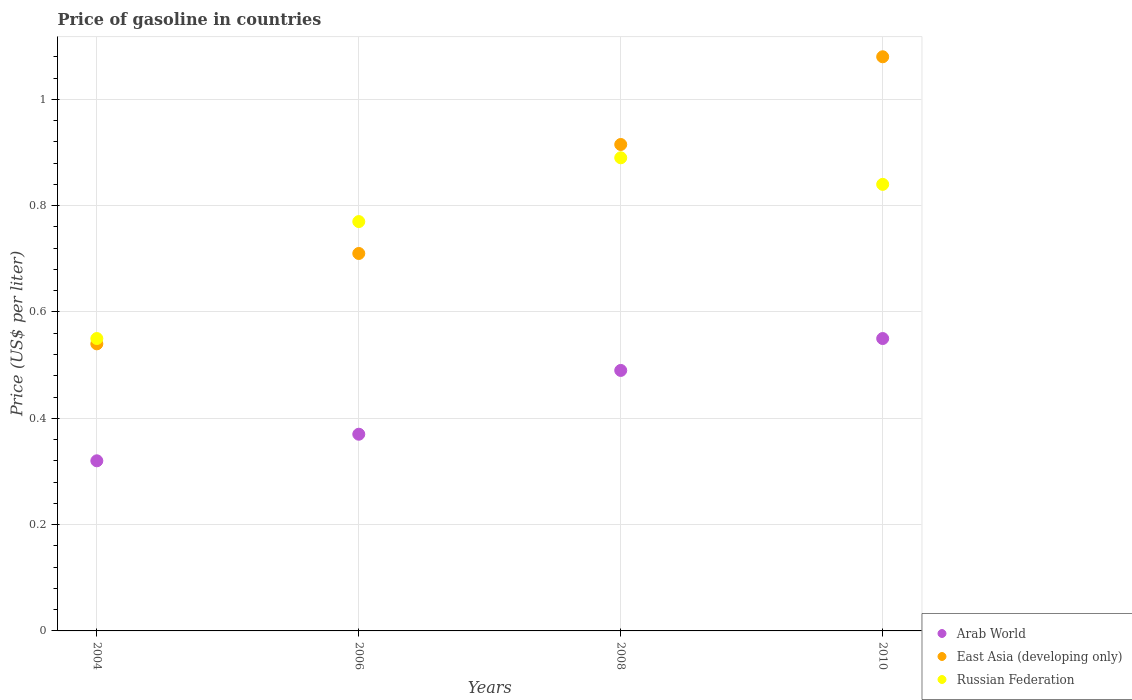Is the number of dotlines equal to the number of legend labels?
Provide a succinct answer. Yes. What is the price of gasoline in East Asia (developing only) in 2008?
Offer a very short reply. 0.92. Across all years, what is the maximum price of gasoline in Arab World?
Your answer should be compact. 0.55. Across all years, what is the minimum price of gasoline in Arab World?
Your response must be concise. 0.32. What is the total price of gasoline in Russian Federation in the graph?
Your answer should be compact. 3.05. What is the difference between the price of gasoline in East Asia (developing only) in 2004 and that in 2006?
Your answer should be compact. -0.17. What is the difference between the price of gasoline in East Asia (developing only) in 2004 and the price of gasoline in Russian Federation in 2008?
Your answer should be very brief. -0.35. What is the average price of gasoline in Arab World per year?
Keep it short and to the point. 0.43. In the year 2008, what is the difference between the price of gasoline in East Asia (developing only) and price of gasoline in Arab World?
Keep it short and to the point. 0.43. In how many years, is the price of gasoline in Arab World greater than 0.52 US$?
Ensure brevity in your answer.  1. What is the ratio of the price of gasoline in Russian Federation in 2006 to that in 2010?
Provide a short and direct response. 0.92. Is the price of gasoline in Arab World in 2008 less than that in 2010?
Your answer should be compact. Yes. What is the difference between the highest and the second highest price of gasoline in Arab World?
Your answer should be compact. 0.06. What is the difference between the highest and the lowest price of gasoline in East Asia (developing only)?
Provide a short and direct response. 0.54. In how many years, is the price of gasoline in East Asia (developing only) greater than the average price of gasoline in East Asia (developing only) taken over all years?
Make the answer very short. 2. Is the sum of the price of gasoline in East Asia (developing only) in 2006 and 2010 greater than the maximum price of gasoline in Russian Federation across all years?
Offer a very short reply. Yes. Is it the case that in every year, the sum of the price of gasoline in East Asia (developing only) and price of gasoline in Russian Federation  is greater than the price of gasoline in Arab World?
Offer a terse response. Yes. Does the price of gasoline in Russian Federation monotonically increase over the years?
Your answer should be compact. No. How many dotlines are there?
Make the answer very short. 3. How many years are there in the graph?
Keep it short and to the point. 4. What is the difference between two consecutive major ticks on the Y-axis?
Provide a succinct answer. 0.2. Does the graph contain grids?
Your answer should be compact. Yes. What is the title of the graph?
Keep it short and to the point. Price of gasoline in countries. Does "Colombia" appear as one of the legend labels in the graph?
Your answer should be very brief. No. What is the label or title of the X-axis?
Provide a succinct answer. Years. What is the label or title of the Y-axis?
Keep it short and to the point. Price (US$ per liter). What is the Price (US$ per liter) of Arab World in 2004?
Provide a succinct answer. 0.32. What is the Price (US$ per liter) of East Asia (developing only) in 2004?
Ensure brevity in your answer.  0.54. What is the Price (US$ per liter) in Russian Federation in 2004?
Offer a very short reply. 0.55. What is the Price (US$ per liter) of Arab World in 2006?
Make the answer very short. 0.37. What is the Price (US$ per liter) of East Asia (developing only) in 2006?
Keep it short and to the point. 0.71. What is the Price (US$ per liter) in Russian Federation in 2006?
Your answer should be very brief. 0.77. What is the Price (US$ per liter) in Arab World in 2008?
Offer a terse response. 0.49. What is the Price (US$ per liter) in East Asia (developing only) in 2008?
Offer a very short reply. 0.92. What is the Price (US$ per liter) of Russian Federation in 2008?
Provide a succinct answer. 0.89. What is the Price (US$ per liter) in Arab World in 2010?
Your answer should be compact. 0.55. What is the Price (US$ per liter) in East Asia (developing only) in 2010?
Make the answer very short. 1.08. What is the Price (US$ per liter) in Russian Federation in 2010?
Your answer should be compact. 0.84. Across all years, what is the maximum Price (US$ per liter) of Arab World?
Your answer should be compact. 0.55. Across all years, what is the maximum Price (US$ per liter) of Russian Federation?
Keep it short and to the point. 0.89. Across all years, what is the minimum Price (US$ per liter) in Arab World?
Give a very brief answer. 0.32. Across all years, what is the minimum Price (US$ per liter) in East Asia (developing only)?
Your answer should be compact. 0.54. Across all years, what is the minimum Price (US$ per liter) in Russian Federation?
Make the answer very short. 0.55. What is the total Price (US$ per liter) in Arab World in the graph?
Ensure brevity in your answer.  1.73. What is the total Price (US$ per liter) in East Asia (developing only) in the graph?
Keep it short and to the point. 3.25. What is the total Price (US$ per liter) of Russian Federation in the graph?
Make the answer very short. 3.05. What is the difference between the Price (US$ per liter) in East Asia (developing only) in 2004 and that in 2006?
Offer a very short reply. -0.17. What is the difference between the Price (US$ per liter) in Russian Federation in 2004 and that in 2006?
Give a very brief answer. -0.22. What is the difference between the Price (US$ per liter) in Arab World in 2004 and that in 2008?
Offer a very short reply. -0.17. What is the difference between the Price (US$ per liter) of East Asia (developing only) in 2004 and that in 2008?
Keep it short and to the point. -0.38. What is the difference between the Price (US$ per liter) in Russian Federation in 2004 and that in 2008?
Your answer should be compact. -0.34. What is the difference between the Price (US$ per liter) in Arab World in 2004 and that in 2010?
Provide a short and direct response. -0.23. What is the difference between the Price (US$ per liter) in East Asia (developing only) in 2004 and that in 2010?
Offer a terse response. -0.54. What is the difference between the Price (US$ per liter) in Russian Federation in 2004 and that in 2010?
Provide a succinct answer. -0.29. What is the difference between the Price (US$ per liter) of Arab World in 2006 and that in 2008?
Give a very brief answer. -0.12. What is the difference between the Price (US$ per liter) in East Asia (developing only) in 2006 and that in 2008?
Provide a short and direct response. -0.2. What is the difference between the Price (US$ per liter) of Russian Federation in 2006 and that in 2008?
Your answer should be compact. -0.12. What is the difference between the Price (US$ per liter) of Arab World in 2006 and that in 2010?
Your response must be concise. -0.18. What is the difference between the Price (US$ per liter) of East Asia (developing only) in 2006 and that in 2010?
Give a very brief answer. -0.37. What is the difference between the Price (US$ per liter) of Russian Federation in 2006 and that in 2010?
Provide a succinct answer. -0.07. What is the difference between the Price (US$ per liter) in Arab World in 2008 and that in 2010?
Make the answer very short. -0.06. What is the difference between the Price (US$ per liter) in East Asia (developing only) in 2008 and that in 2010?
Offer a terse response. -0.17. What is the difference between the Price (US$ per liter) of Russian Federation in 2008 and that in 2010?
Ensure brevity in your answer.  0.05. What is the difference between the Price (US$ per liter) in Arab World in 2004 and the Price (US$ per liter) in East Asia (developing only) in 2006?
Provide a short and direct response. -0.39. What is the difference between the Price (US$ per liter) in Arab World in 2004 and the Price (US$ per liter) in Russian Federation in 2006?
Your answer should be compact. -0.45. What is the difference between the Price (US$ per liter) in East Asia (developing only) in 2004 and the Price (US$ per liter) in Russian Federation in 2006?
Offer a terse response. -0.23. What is the difference between the Price (US$ per liter) in Arab World in 2004 and the Price (US$ per liter) in East Asia (developing only) in 2008?
Your response must be concise. -0.59. What is the difference between the Price (US$ per liter) of Arab World in 2004 and the Price (US$ per liter) of Russian Federation in 2008?
Give a very brief answer. -0.57. What is the difference between the Price (US$ per liter) in East Asia (developing only) in 2004 and the Price (US$ per liter) in Russian Federation in 2008?
Offer a very short reply. -0.35. What is the difference between the Price (US$ per liter) of Arab World in 2004 and the Price (US$ per liter) of East Asia (developing only) in 2010?
Ensure brevity in your answer.  -0.76. What is the difference between the Price (US$ per liter) in Arab World in 2004 and the Price (US$ per liter) in Russian Federation in 2010?
Make the answer very short. -0.52. What is the difference between the Price (US$ per liter) in East Asia (developing only) in 2004 and the Price (US$ per liter) in Russian Federation in 2010?
Ensure brevity in your answer.  -0.3. What is the difference between the Price (US$ per liter) of Arab World in 2006 and the Price (US$ per liter) of East Asia (developing only) in 2008?
Your answer should be very brief. -0.55. What is the difference between the Price (US$ per liter) in Arab World in 2006 and the Price (US$ per liter) in Russian Federation in 2008?
Your response must be concise. -0.52. What is the difference between the Price (US$ per liter) of East Asia (developing only) in 2006 and the Price (US$ per liter) of Russian Federation in 2008?
Ensure brevity in your answer.  -0.18. What is the difference between the Price (US$ per liter) of Arab World in 2006 and the Price (US$ per liter) of East Asia (developing only) in 2010?
Your response must be concise. -0.71. What is the difference between the Price (US$ per liter) of Arab World in 2006 and the Price (US$ per liter) of Russian Federation in 2010?
Give a very brief answer. -0.47. What is the difference between the Price (US$ per liter) of East Asia (developing only) in 2006 and the Price (US$ per liter) of Russian Federation in 2010?
Your answer should be compact. -0.13. What is the difference between the Price (US$ per liter) of Arab World in 2008 and the Price (US$ per liter) of East Asia (developing only) in 2010?
Your answer should be very brief. -0.59. What is the difference between the Price (US$ per liter) of Arab World in 2008 and the Price (US$ per liter) of Russian Federation in 2010?
Give a very brief answer. -0.35. What is the difference between the Price (US$ per liter) of East Asia (developing only) in 2008 and the Price (US$ per liter) of Russian Federation in 2010?
Make the answer very short. 0.07. What is the average Price (US$ per liter) of Arab World per year?
Your response must be concise. 0.43. What is the average Price (US$ per liter) in East Asia (developing only) per year?
Your answer should be very brief. 0.81. What is the average Price (US$ per liter) of Russian Federation per year?
Keep it short and to the point. 0.76. In the year 2004, what is the difference between the Price (US$ per liter) of Arab World and Price (US$ per liter) of East Asia (developing only)?
Provide a succinct answer. -0.22. In the year 2004, what is the difference between the Price (US$ per liter) of Arab World and Price (US$ per liter) of Russian Federation?
Your answer should be compact. -0.23. In the year 2004, what is the difference between the Price (US$ per liter) in East Asia (developing only) and Price (US$ per liter) in Russian Federation?
Give a very brief answer. -0.01. In the year 2006, what is the difference between the Price (US$ per liter) in Arab World and Price (US$ per liter) in East Asia (developing only)?
Give a very brief answer. -0.34. In the year 2006, what is the difference between the Price (US$ per liter) in Arab World and Price (US$ per liter) in Russian Federation?
Offer a terse response. -0.4. In the year 2006, what is the difference between the Price (US$ per liter) of East Asia (developing only) and Price (US$ per liter) of Russian Federation?
Provide a succinct answer. -0.06. In the year 2008, what is the difference between the Price (US$ per liter) of Arab World and Price (US$ per liter) of East Asia (developing only)?
Provide a short and direct response. -0.42. In the year 2008, what is the difference between the Price (US$ per liter) in Arab World and Price (US$ per liter) in Russian Federation?
Your answer should be very brief. -0.4. In the year 2008, what is the difference between the Price (US$ per liter) of East Asia (developing only) and Price (US$ per liter) of Russian Federation?
Make the answer very short. 0.03. In the year 2010, what is the difference between the Price (US$ per liter) of Arab World and Price (US$ per liter) of East Asia (developing only)?
Provide a succinct answer. -0.53. In the year 2010, what is the difference between the Price (US$ per liter) of Arab World and Price (US$ per liter) of Russian Federation?
Ensure brevity in your answer.  -0.29. In the year 2010, what is the difference between the Price (US$ per liter) in East Asia (developing only) and Price (US$ per liter) in Russian Federation?
Ensure brevity in your answer.  0.24. What is the ratio of the Price (US$ per liter) of Arab World in 2004 to that in 2006?
Your answer should be compact. 0.86. What is the ratio of the Price (US$ per liter) in East Asia (developing only) in 2004 to that in 2006?
Ensure brevity in your answer.  0.76. What is the ratio of the Price (US$ per liter) in Russian Federation in 2004 to that in 2006?
Your response must be concise. 0.71. What is the ratio of the Price (US$ per liter) in Arab World in 2004 to that in 2008?
Provide a succinct answer. 0.65. What is the ratio of the Price (US$ per liter) in East Asia (developing only) in 2004 to that in 2008?
Your answer should be compact. 0.59. What is the ratio of the Price (US$ per liter) of Russian Federation in 2004 to that in 2008?
Provide a succinct answer. 0.62. What is the ratio of the Price (US$ per liter) of Arab World in 2004 to that in 2010?
Give a very brief answer. 0.58. What is the ratio of the Price (US$ per liter) in Russian Federation in 2004 to that in 2010?
Ensure brevity in your answer.  0.65. What is the ratio of the Price (US$ per liter) in Arab World in 2006 to that in 2008?
Keep it short and to the point. 0.76. What is the ratio of the Price (US$ per liter) in East Asia (developing only) in 2006 to that in 2008?
Give a very brief answer. 0.78. What is the ratio of the Price (US$ per liter) in Russian Federation in 2006 to that in 2008?
Provide a succinct answer. 0.87. What is the ratio of the Price (US$ per liter) of Arab World in 2006 to that in 2010?
Ensure brevity in your answer.  0.67. What is the ratio of the Price (US$ per liter) in East Asia (developing only) in 2006 to that in 2010?
Provide a short and direct response. 0.66. What is the ratio of the Price (US$ per liter) in Arab World in 2008 to that in 2010?
Your response must be concise. 0.89. What is the ratio of the Price (US$ per liter) of East Asia (developing only) in 2008 to that in 2010?
Your answer should be compact. 0.85. What is the ratio of the Price (US$ per liter) in Russian Federation in 2008 to that in 2010?
Make the answer very short. 1.06. What is the difference between the highest and the second highest Price (US$ per liter) in Arab World?
Provide a succinct answer. 0.06. What is the difference between the highest and the second highest Price (US$ per liter) of East Asia (developing only)?
Your answer should be very brief. 0.17. What is the difference between the highest and the lowest Price (US$ per liter) in Arab World?
Keep it short and to the point. 0.23. What is the difference between the highest and the lowest Price (US$ per liter) in East Asia (developing only)?
Give a very brief answer. 0.54. What is the difference between the highest and the lowest Price (US$ per liter) of Russian Federation?
Provide a short and direct response. 0.34. 